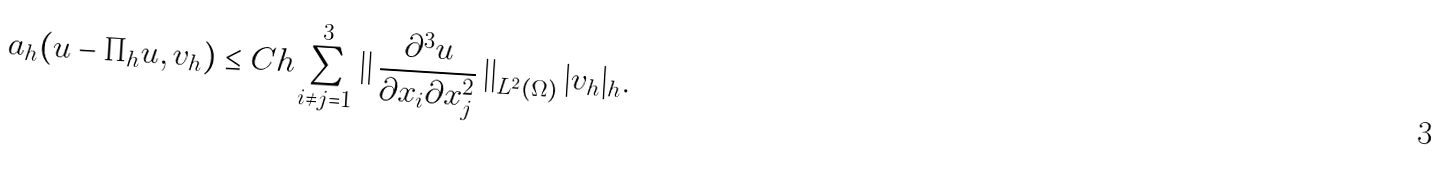Convert formula to latex. <formula><loc_0><loc_0><loc_500><loc_500>a _ { h } ( u - \Pi _ { h } u , v _ { h } ) \leq C h \sum _ { i \neq j = 1 } ^ { 3 } \left | \right | \frac { \partial ^ { 3 } u } { \partial x _ { i } \partial x _ { j } ^ { 2 } } \left | \right | _ { L ^ { 2 } ( \Omega ) } | v _ { h } | _ { h } .</formula> 